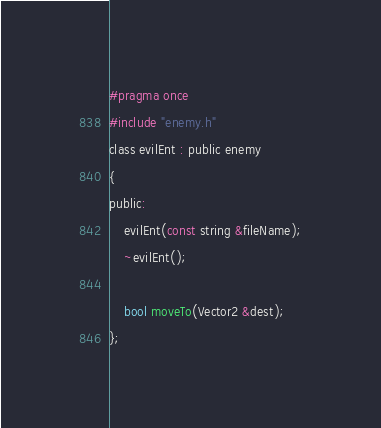<code> <loc_0><loc_0><loc_500><loc_500><_C_>#pragma once
#include "enemy.h"
class evilEnt : public enemy
{
public:
	evilEnt(const string &fileName);
	~evilEnt();

	bool moveTo(Vector2 &dest);
};

</code> 